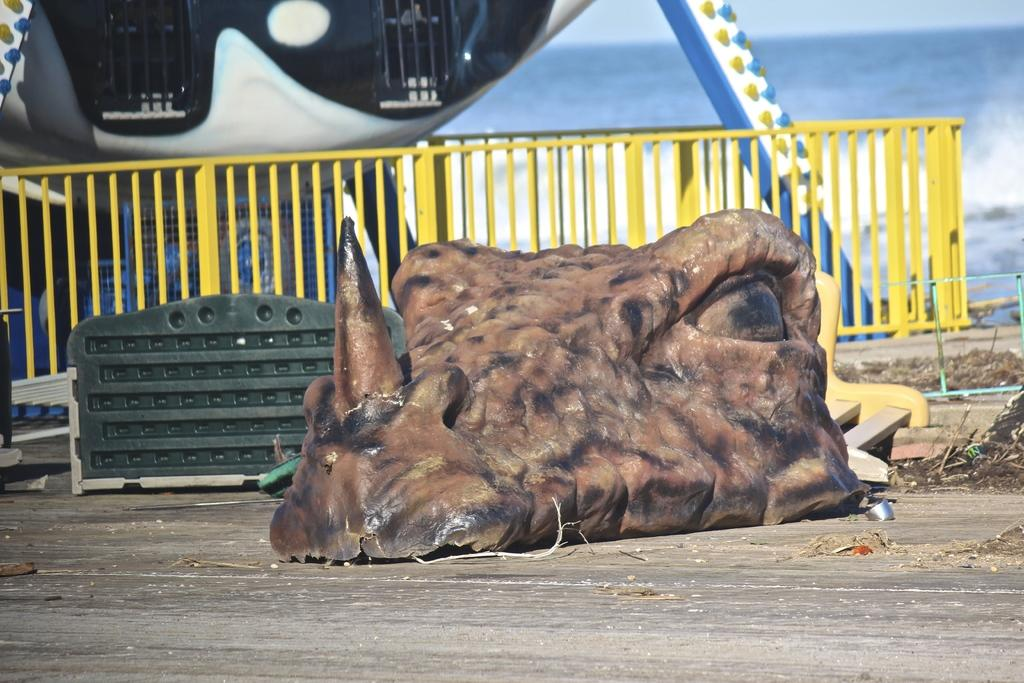What is the main subject of the image that resembles an animal face? There is an object that resembles an animal face in the image. What type of structure can be seen in the image? There is railing visible in the image, which suggests a structure or barrier of some kind. What natural element is present in the image? There is water in the image. What is visible at the top of the image? The sky is visible at the top of the image. What type of gold object is floating in the water in the image? There is no gold object present in the image; it only features an animal face-like object, railing, water, and the sky. 